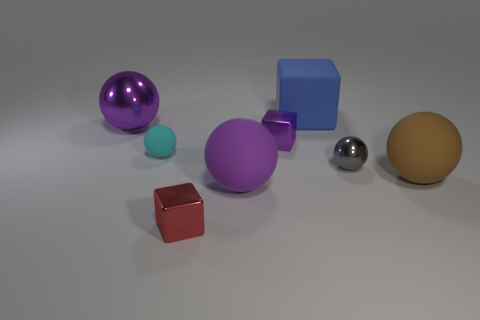Subtract all red cubes. How many purple spheres are left? 2 Subtract all large purple metallic balls. How many balls are left? 4 Subtract all cyan balls. How many balls are left? 4 Subtract 1 blocks. How many blocks are left? 2 Add 1 blue things. How many objects exist? 9 Subtract all red balls. Subtract all yellow cylinders. How many balls are left? 5 Subtract all blocks. How many objects are left? 5 Add 1 big purple metallic objects. How many big purple metallic objects are left? 2 Add 5 brown things. How many brown things exist? 6 Subtract 1 gray spheres. How many objects are left? 7 